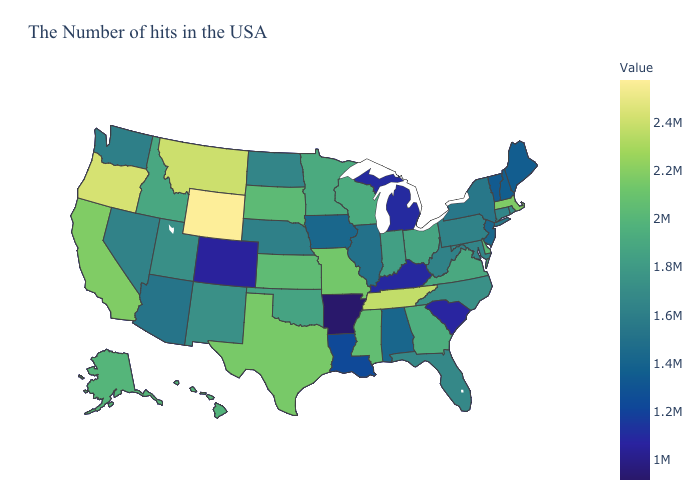Does Wyoming have the highest value in the USA?
Keep it brief. Yes. Among the states that border Connecticut , does Rhode Island have the highest value?
Be succinct. No. Does the map have missing data?
Concise answer only. No. Among the states that border North Carolina , which have the lowest value?
Answer briefly. South Carolina. Does Massachusetts have the highest value in the Northeast?
Be succinct. Yes. Does Colorado have the lowest value in the West?
Keep it brief. Yes. 